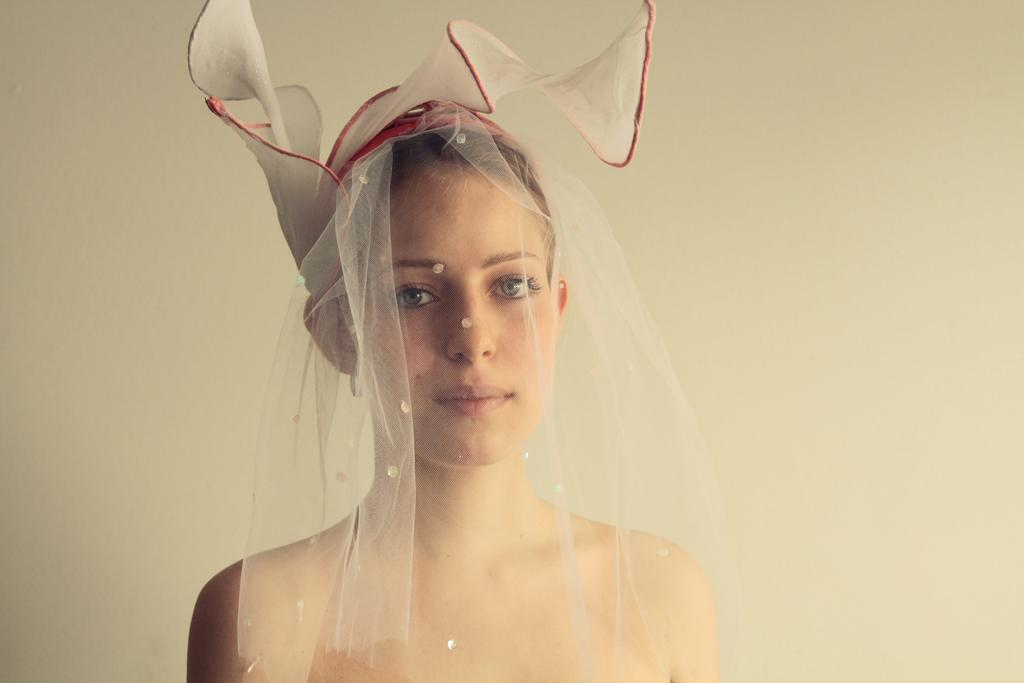Who is the main subject in the image? There is a lady in the center of the image. What is the lady wearing on her head? The lady is wearing a hair net. What can be seen in the background of the image? There is a wall in the background of the image. What type of beast can be seen running in the background of the image? There is no beast present in the image; it only features a lady and a wall in the background. 